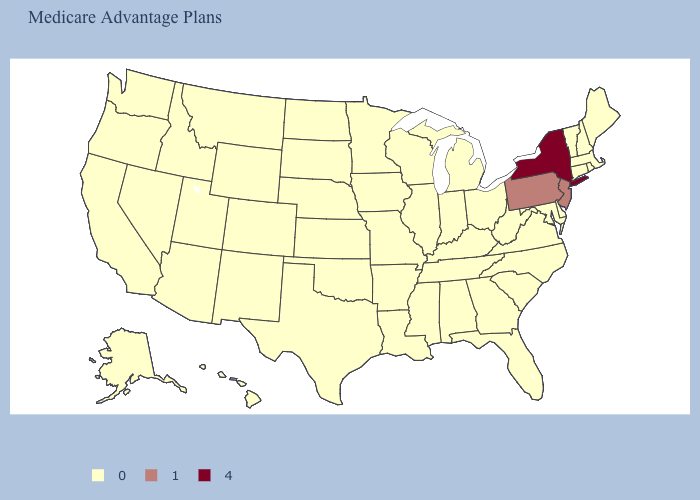What is the highest value in the USA?
Keep it brief. 4. What is the value of North Carolina?
Be succinct. 0. Does New York have the highest value in the USA?
Answer briefly. Yes. Among the states that border South Carolina , which have the lowest value?
Be succinct. Georgia, North Carolina. How many symbols are there in the legend?
Short answer required. 3. What is the value of Montana?
Keep it brief. 0. Name the states that have a value in the range 0?
Short answer required. Alaska, Alabama, Arkansas, Arizona, California, Colorado, Connecticut, Delaware, Florida, Georgia, Hawaii, Iowa, Idaho, Illinois, Indiana, Kansas, Kentucky, Louisiana, Massachusetts, Maryland, Maine, Michigan, Minnesota, Missouri, Mississippi, Montana, North Carolina, North Dakota, Nebraska, New Hampshire, New Mexico, Nevada, Ohio, Oklahoma, Oregon, Rhode Island, South Carolina, South Dakota, Tennessee, Texas, Utah, Virginia, Vermont, Washington, Wisconsin, West Virginia, Wyoming. Among the states that border Utah , which have the highest value?
Concise answer only. Arizona, Colorado, Idaho, New Mexico, Nevada, Wyoming. What is the value of West Virginia?
Answer briefly. 0. Name the states that have a value in the range 4?
Answer briefly. New York. What is the value of Colorado?
Short answer required. 0. Which states have the lowest value in the USA?
Be succinct. Alaska, Alabama, Arkansas, Arizona, California, Colorado, Connecticut, Delaware, Florida, Georgia, Hawaii, Iowa, Idaho, Illinois, Indiana, Kansas, Kentucky, Louisiana, Massachusetts, Maryland, Maine, Michigan, Minnesota, Missouri, Mississippi, Montana, North Carolina, North Dakota, Nebraska, New Hampshire, New Mexico, Nevada, Ohio, Oklahoma, Oregon, Rhode Island, South Carolina, South Dakota, Tennessee, Texas, Utah, Virginia, Vermont, Washington, Wisconsin, West Virginia, Wyoming. Does New York have the highest value in the USA?
Answer briefly. Yes. Name the states that have a value in the range 1?
Answer briefly. New Jersey, Pennsylvania. 